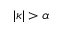<formula> <loc_0><loc_0><loc_500><loc_500>| \kappa | > \alpha</formula> 